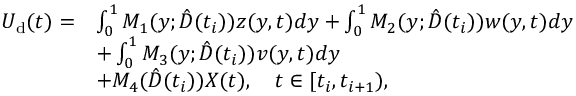<formula> <loc_0><loc_0><loc_500><loc_500>\begin{array} { r l } { U _ { d } ( t ) = } & { \int _ { 0 } ^ { 1 } M _ { 1 } ( y ; \hat { D } ( t _ { i } ) ) z ( y , t ) d y + \int _ { 0 } ^ { 1 } M _ { 2 } ( y ; \hat { D } ( t _ { i } ) ) w ( y , t ) d y } \\ & { + \int _ { 0 } ^ { 1 } M _ { 3 } ( y ; \hat { D } ( t _ { i } ) ) v ( y , t ) d y } \\ & { + M _ { 4 } ( \hat { D } ( t _ { i } ) ) X ( t ) , \quad t \in [ t _ { i } , t _ { i + 1 } ) , } \end{array}</formula> 